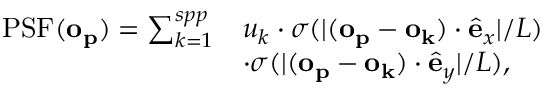<formula> <loc_0><loc_0><loc_500><loc_500>\begin{array} { r l } { P S F ( o _ { p } ) = \sum _ { k = 1 } ^ { s p p } } & { u _ { k } \cdot \sigma ( | ( o _ { p } - o _ { k } ) \cdot \hat { e } _ { x } | / L ) } \\ & { \cdot \sigma ( | ( o _ { p } - o _ { k } ) \cdot \hat { e } _ { y } | / L ) , } \end{array}</formula> 